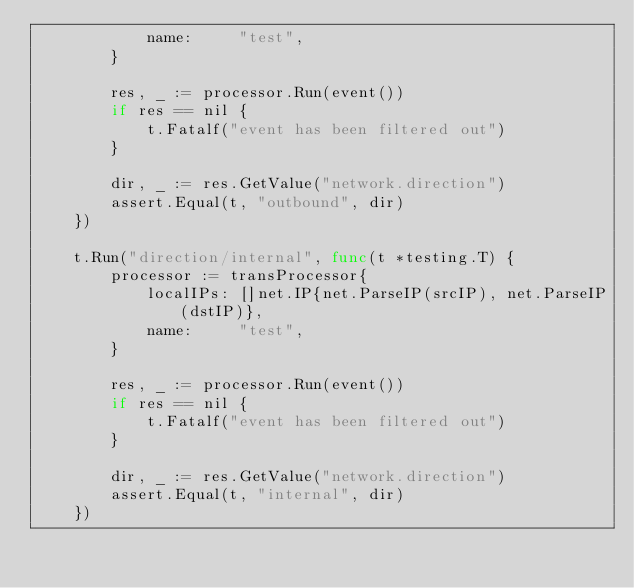<code> <loc_0><loc_0><loc_500><loc_500><_Go_>			name:     "test",
		}

		res, _ := processor.Run(event())
		if res == nil {
			t.Fatalf("event has been filtered out")
		}

		dir, _ := res.GetValue("network.direction")
		assert.Equal(t, "outbound", dir)
	})

	t.Run("direction/internal", func(t *testing.T) {
		processor := transProcessor{
			localIPs: []net.IP{net.ParseIP(srcIP), net.ParseIP(dstIP)},
			name:     "test",
		}

		res, _ := processor.Run(event())
		if res == nil {
			t.Fatalf("event has been filtered out")
		}

		dir, _ := res.GetValue("network.direction")
		assert.Equal(t, "internal", dir)
	})
</code> 